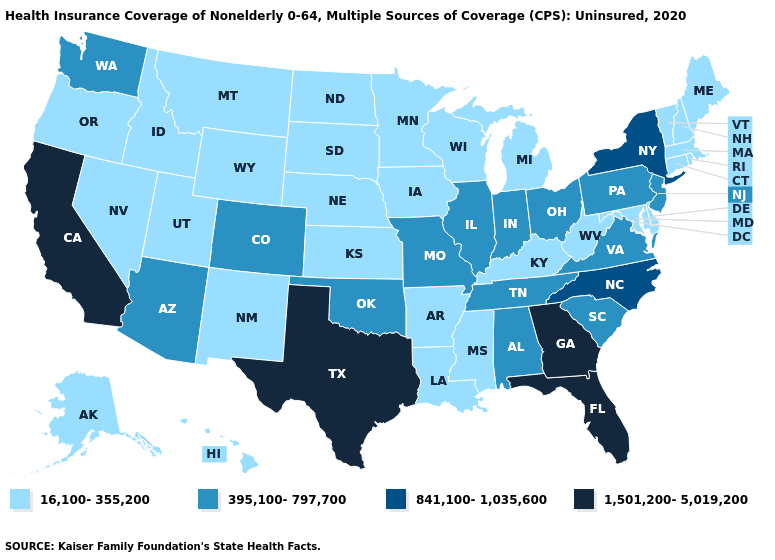Name the states that have a value in the range 841,100-1,035,600?
Quick response, please. New York, North Carolina. What is the lowest value in the South?
Concise answer only. 16,100-355,200. Which states have the lowest value in the USA?
Answer briefly. Alaska, Arkansas, Connecticut, Delaware, Hawaii, Idaho, Iowa, Kansas, Kentucky, Louisiana, Maine, Maryland, Massachusetts, Michigan, Minnesota, Mississippi, Montana, Nebraska, Nevada, New Hampshire, New Mexico, North Dakota, Oregon, Rhode Island, South Dakota, Utah, Vermont, West Virginia, Wisconsin, Wyoming. What is the value of Idaho?
Short answer required. 16,100-355,200. What is the value of Ohio?
Answer briefly. 395,100-797,700. Name the states that have a value in the range 16,100-355,200?
Short answer required. Alaska, Arkansas, Connecticut, Delaware, Hawaii, Idaho, Iowa, Kansas, Kentucky, Louisiana, Maine, Maryland, Massachusetts, Michigan, Minnesota, Mississippi, Montana, Nebraska, Nevada, New Hampshire, New Mexico, North Dakota, Oregon, Rhode Island, South Dakota, Utah, Vermont, West Virginia, Wisconsin, Wyoming. Name the states that have a value in the range 1,501,200-5,019,200?
Give a very brief answer. California, Florida, Georgia, Texas. What is the value of Oregon?
Answer briefly. 16,100-355,200. Which states have the highest value in the USA?
Be succinct. California, Florida, Georgia, Texas. Name the states that have a value in the range 16,100-355,200?
Be succinct. Alaska, Arkansas, Connecticut, Delaware, Hawaii, Idaho, Iowa, Kansas, Kentucky, Louisiana, Maine, Maryland, Massachusetts, Michigan, Minnesota, Mississippi, Montana, Nebraska, Nevada, New Hampshire, New Mexico, North Dakota, Oregon, Rhode Island, South Dakota, Utah, Vermont, West Virginia, Wisconsin, Wyoming. Name the states that have a value in the range 841,100-1,035,600?
Concise answer only. New York, North Carolina. What is the value of Washington?
Be succinct. 395,100-797,700. Name the states that have a value in the range 841,100-1,035,600?
Concise answer only. New York, North Carolina. Name the states that have a value in the range 16,100-355,200?
Give a very brief answer. Alaska, Arkansas, Connecticut, Delaware, Hawaii, Idaho, Iowa, Kansas, Kentucky, Louisiana, Maine, Maryland, Massachusetts, Michigan, Minnesota, Mississippi, Montana, Nebraska, Nevada, New Hampshire, New Mexico, North Dakota, Oregon, Rhode Island, South Dakota, Utah, Vermont, West Virginia, Wisconsin, Wyoming. What is the value of Iowa?
Concise answer only. 16,100-355,200. 